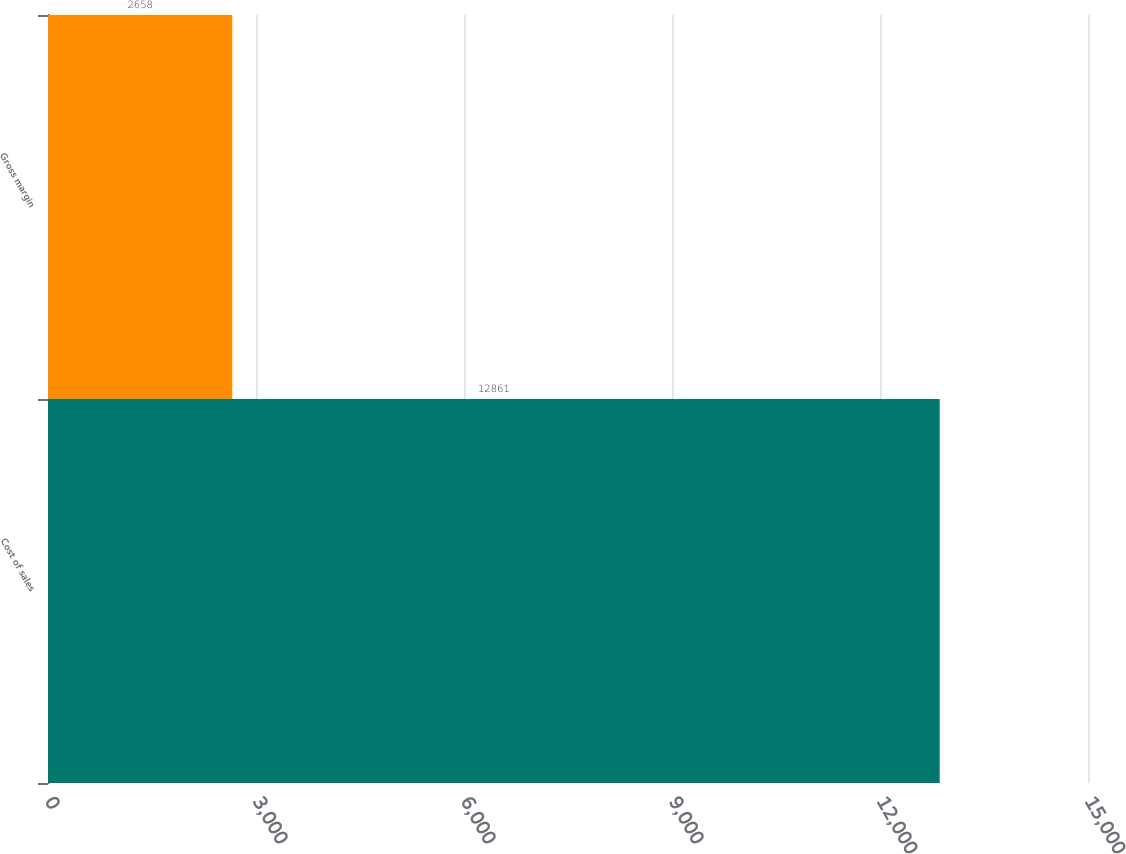Convert chart. <chart><loc_0><loc_0><loc_500><loc_500><bar_chart><fcel>Cost of sales<fcel>Gross margin<nl><fcel>12861<fcel>2658<nl></chart> 